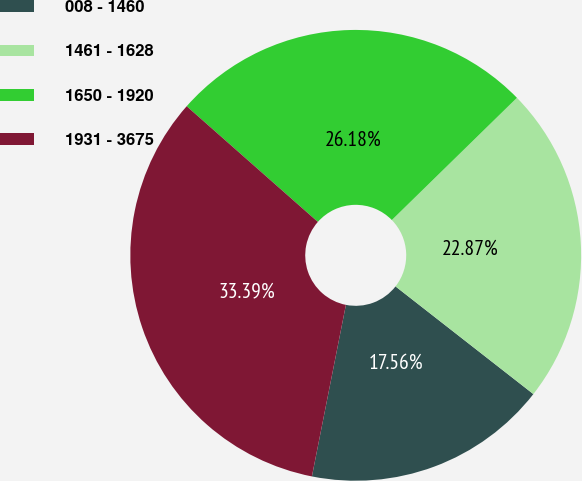Convert chart. <chart><loc_0><loc_0><loc_500><loc_500><pie_chart><fcel>008 - 1460<fcel>1461 - 1628<fcel>1650 - 1920<fcel>1931 - 3675<nl><fcel>17.56%<fcel>22.87%<fcel>26.18%<fcel>33.39%<nl></chart> 